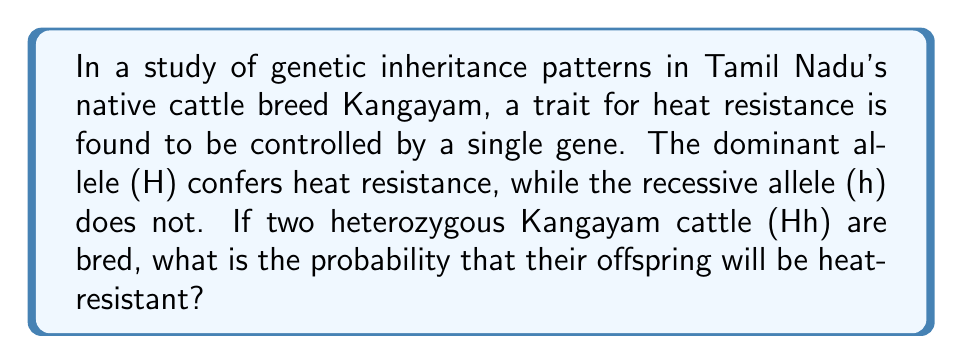What is the answer to this math problem? To solve this problem, we'll use the principles of Mendelian genetics and probability theory:

1. First, let's identify the genotypes:
   - Parents: Both are heterozygous (Hh)
   - Offspring possibilities: HH, Hh, hh

2. We can use a Punnett square to visualize the possible outcomes:

   $$\begin{array}{c|c|c}
     & H & h \\
   \hline
   H & HH & Hh \\
   \hline
   h & Hh & hh
   \end{array}$$

3. From the Punnett square, we can see:
   - 1 possibility for HH (homozygous dominant)
   - 2 possibilities for Hh (heterozygous)
   - 1 possibility for hh (homozygous recessive)

4. The trait for heat resistance is dominant, so both HH and Hh genotypes will express heat resistance.

5. To calculate the probability:
   - Favorable outcomes: HH + Hh + Hh = 3
   - Total outcomes: 4

6. The probability is calculated as:

   $$P(\text{heat-resistant}) = \frac{\text{favorable outcomes}}{\text{total outcomes}} = \frac{3}{4} = 0.75$$

Therefore, the probability that the offspring will be heat-resistant is 0.75 or 75%.
Answer: $\frac{3}{4}$ or 0.75 or 75% 